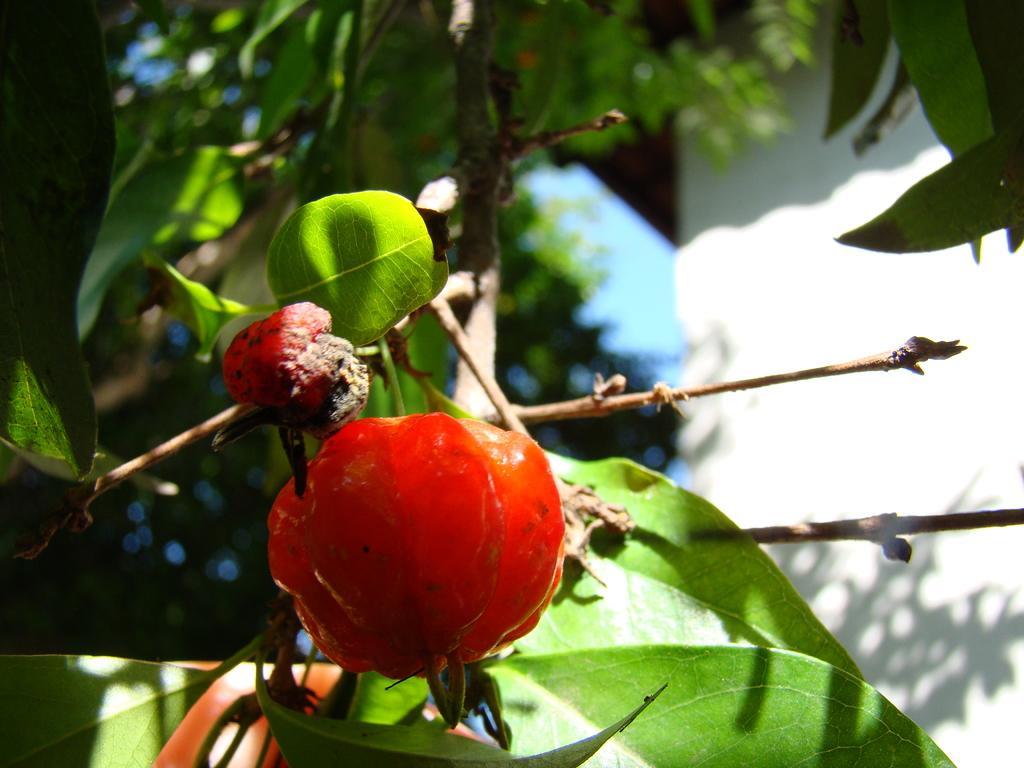Describe this image in one or two sentences. In this image there is an orange colour fruit in the middle. In the background there are stems with the green leaves. On the right side there is a wall. 